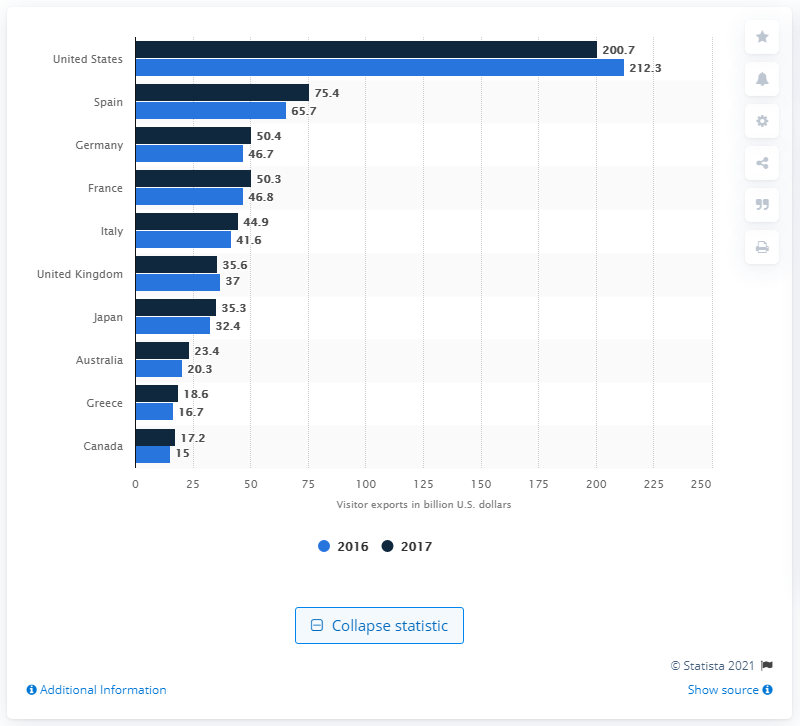Draw attention to some important aspects in this diagram. In 2017, the value of visitor exports from Spain in U.S. dollars was approximately 75.4 billion. 